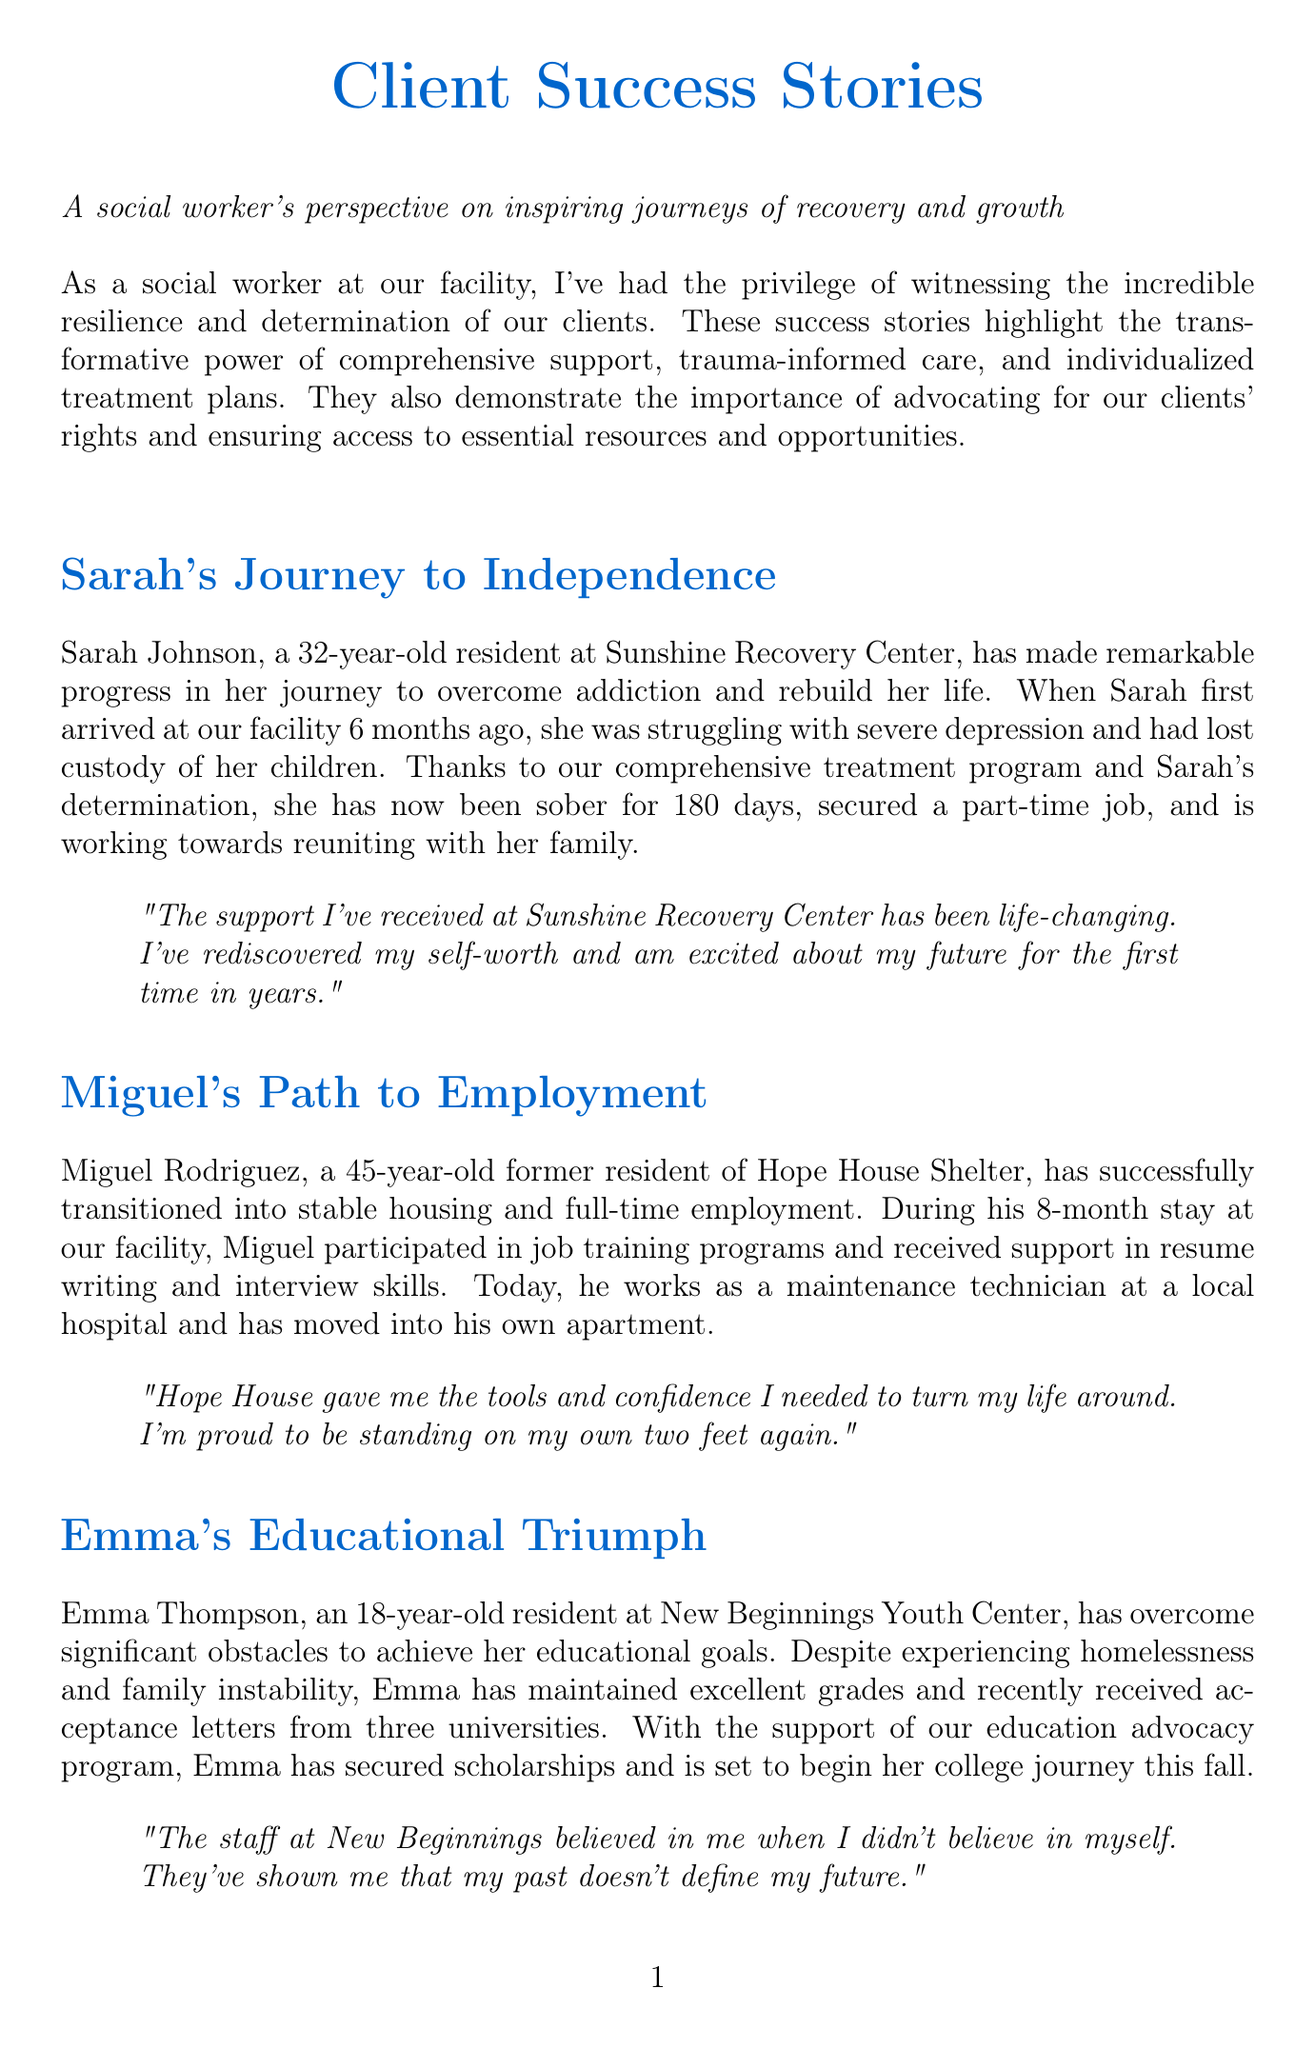What is the title of Sarah's story? The title of Sarah's story is mentioned at the beginning of her section.
Answer: Sarah's Journey to Independence How long did Miguel stay at Hope House Shelter? The document states the duration of Miguel's stay during his transition to stable housing.
Answer: 8 months What job does Emma Thompson have after her educational achievements? The document mentions that Emma received acceptance letters from universities, but does not specify a job.
Answer: None specified What is John's age? John Anderson's age is stated at the beginning of his section in the document.
Answer: 55 years old What recovery program did Maria complete? The document specifically names the program that helped Maria regain custody of her children.
Answer: Family Reunification Program What is the main theme reflected in the success stories? The overarching theme connects the individual triumphs of clients and their communities in the document.
Answer: Resilience and support How many universities did Emma receive acceptance letters from? The document provides the exact number of universities Emma received letters from.
Answer: Three What is the location of Sarah's recovery center? The document mentions the name of the facility where Sarah is receiving treatment.
Answer: Sunshine Recovery Center What aspect of the stories is commonly highlighted? The document emphasizes a particular benefit or outcome of the programs mentioned in the success stories.
Answer: Transformation and empowerment 